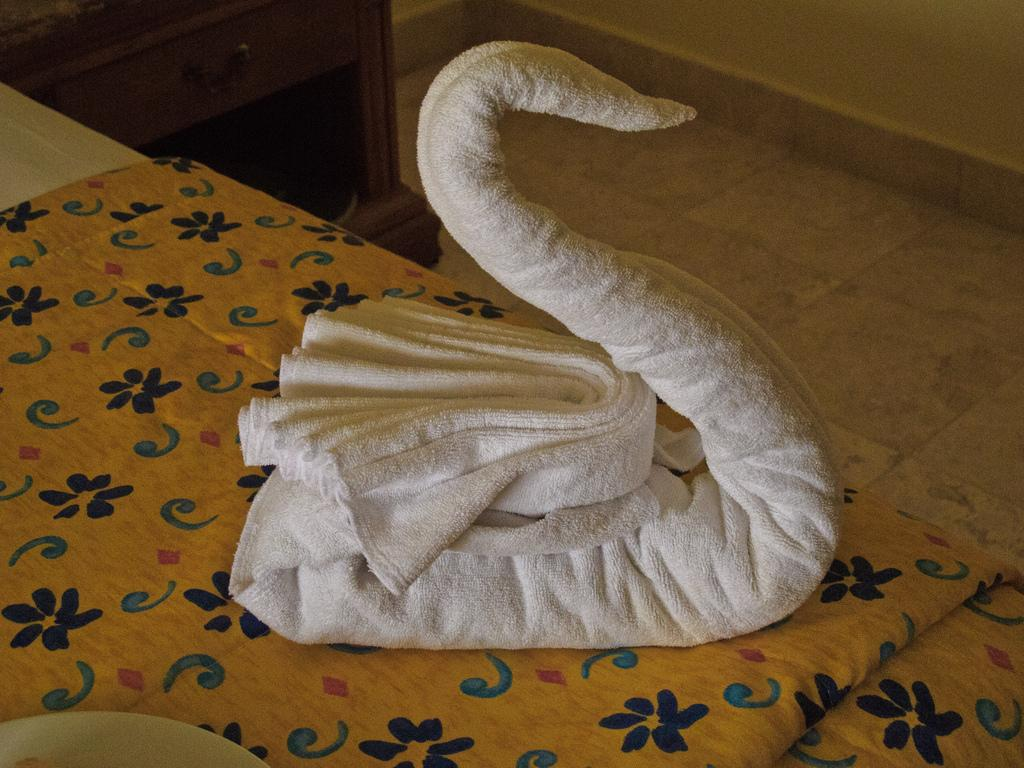What is there is a towel on the bed in the image. What is the purpose of the towel? The towel on the bed may be used for decoration or as a cover for the bed. What can be seen in the background of the image? In the background of the image, there is a wall and a cupboard. What part of the room is visible to the right side of the image? The floor is visible to the right side of the image. What type of clover is growing on the wall in the image? There is no clover present in the image; the wall is a plain background. What type of berry can be seen on the towel in the image? There are no berries present on the towel or in the image. 